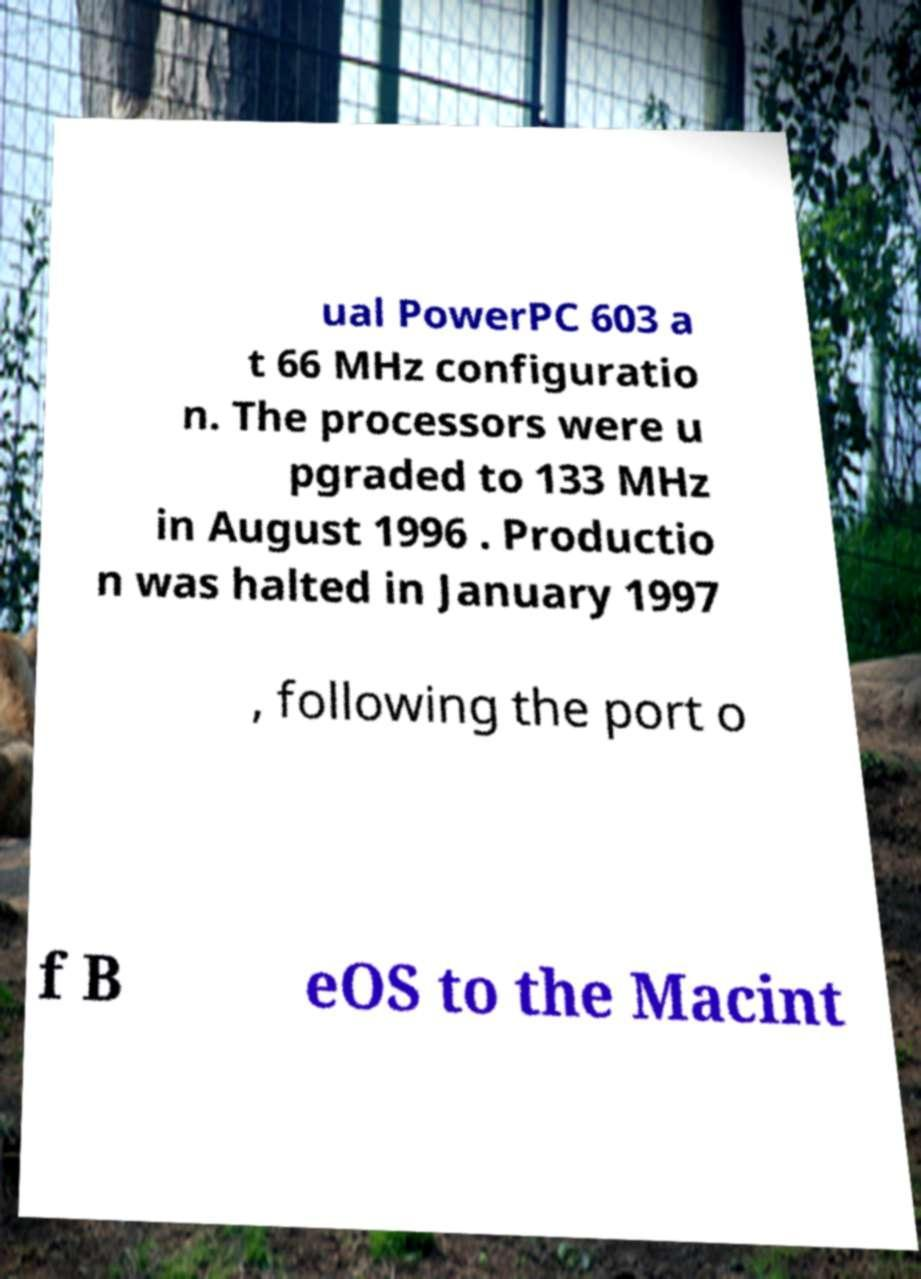Can you read and provide the text displayed in the image?This photo seems to have some interesting text. Can you extract and type it out for me? ual PowerPC 603 a t 66 MHz configuratio n. The processors were u pgraded to 133 MHz in August 1996 . Productio n was halted in January 1997 , following the port o f B eOS to the Macint 